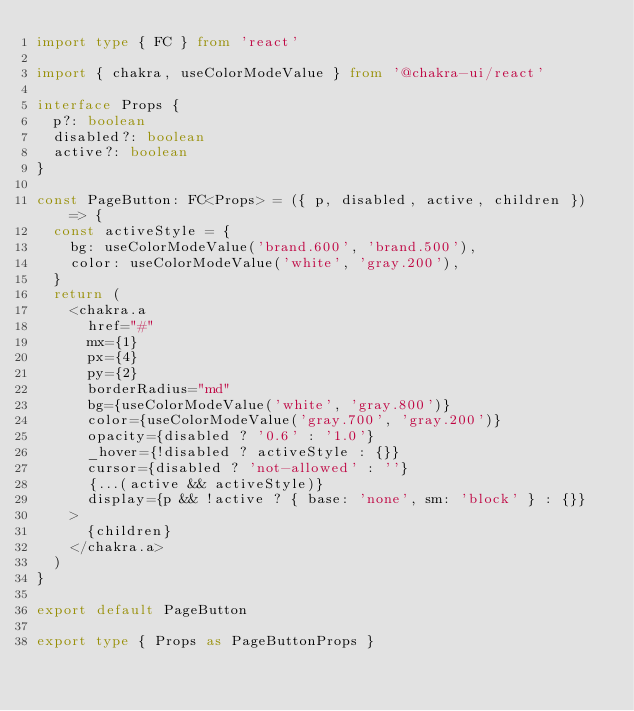Convert code to text. <code><loc_0><loc_0><loc_500><loc_500><_TypeScript_>import type { FC } from 'react'

import { chakra, useColorModeValue } from '@chakra-ui/react'

interface Props {
  p?: boolean
  disabled?: boolean
  active?: boolean
}

const PageButton: FC<Props> = ({ p, disabled, active, children }) => {
  const activeStyle = {
    bg: useColorModeValue('brand.600', 'brand.500'),
    color: useColorModeValue('white', 'gray.200'),
  }
  return (
    <chakra.a
      href="#"
      mx={1}
      px={4}
      py={2}
      borderRadius="md"
      bg={useColorModeValue('white', 'gray.800')}
      color={useColorModeValue('gray.700', 'gray.200')}
      opacity={disabled ? '0.6' : '1.0'}
      _hover={!disabled ? activeStyle : {}}
      cursor={disabled ? 'not-allowed' : ''}
      {...(active && activeStyle)}
      display={p && !active ? { base: 'none', sm: 'block' } : {}}
    >
      {children}
    </chakra.a>
  )
}

export default PageButton

export type { Props as PageButtonProps }
</code> 